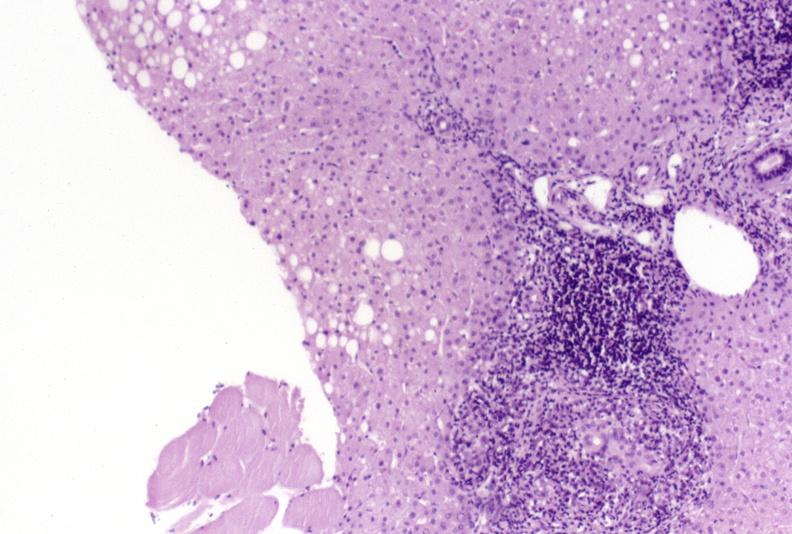does this image show primary biliary cirrhosis?
Answer the question using a single word or phrase. Yes 